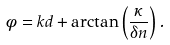<formula> <loc_0><loc_0><loc_500><loc_500>\phi = k d + \arctan \left ( \frac { \kappa } { \delta n } \right ) .</formula> 